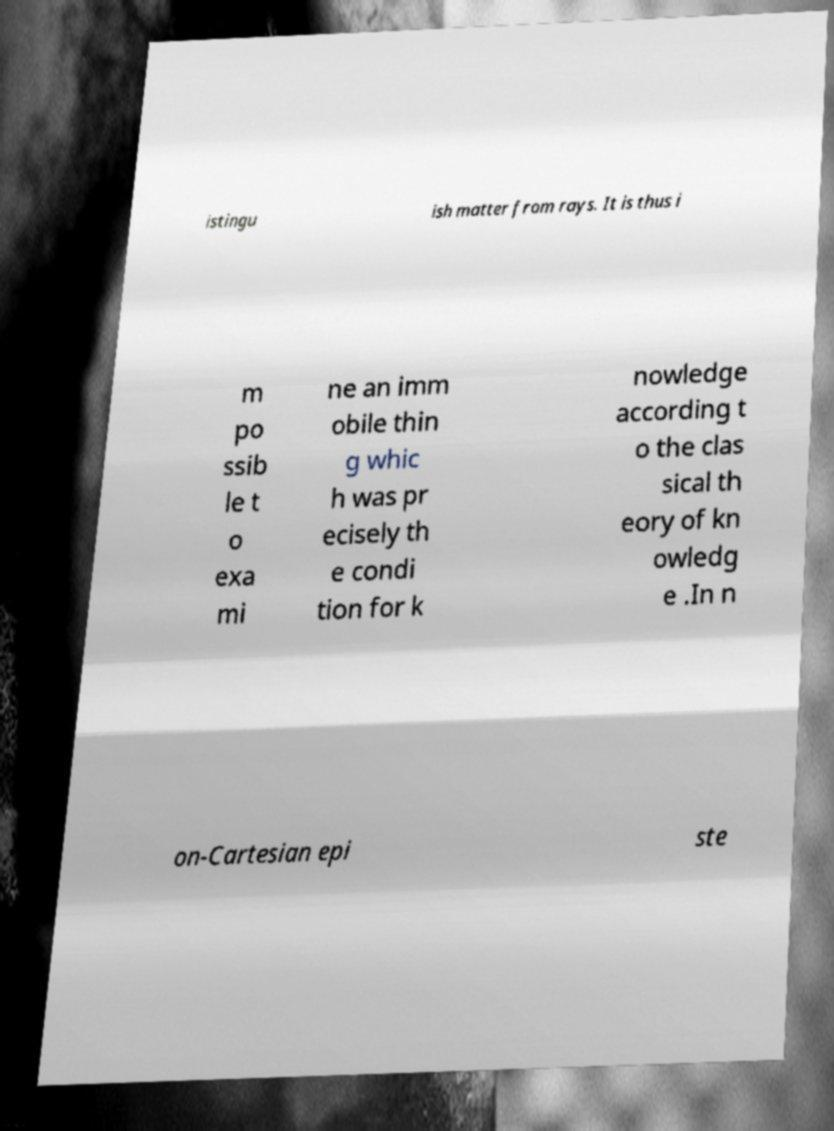What messages or text are displayed in this image? I need them in a readable, typed format. istingu ish matter from rays. It is thus i m po ssib le t o exa mi ne an imm obile thin g whic h was pr ecisely th e condi tion for k nowledge according t o the clas sical th eory of kn owledg e .In n on-Cartesian epi ste 